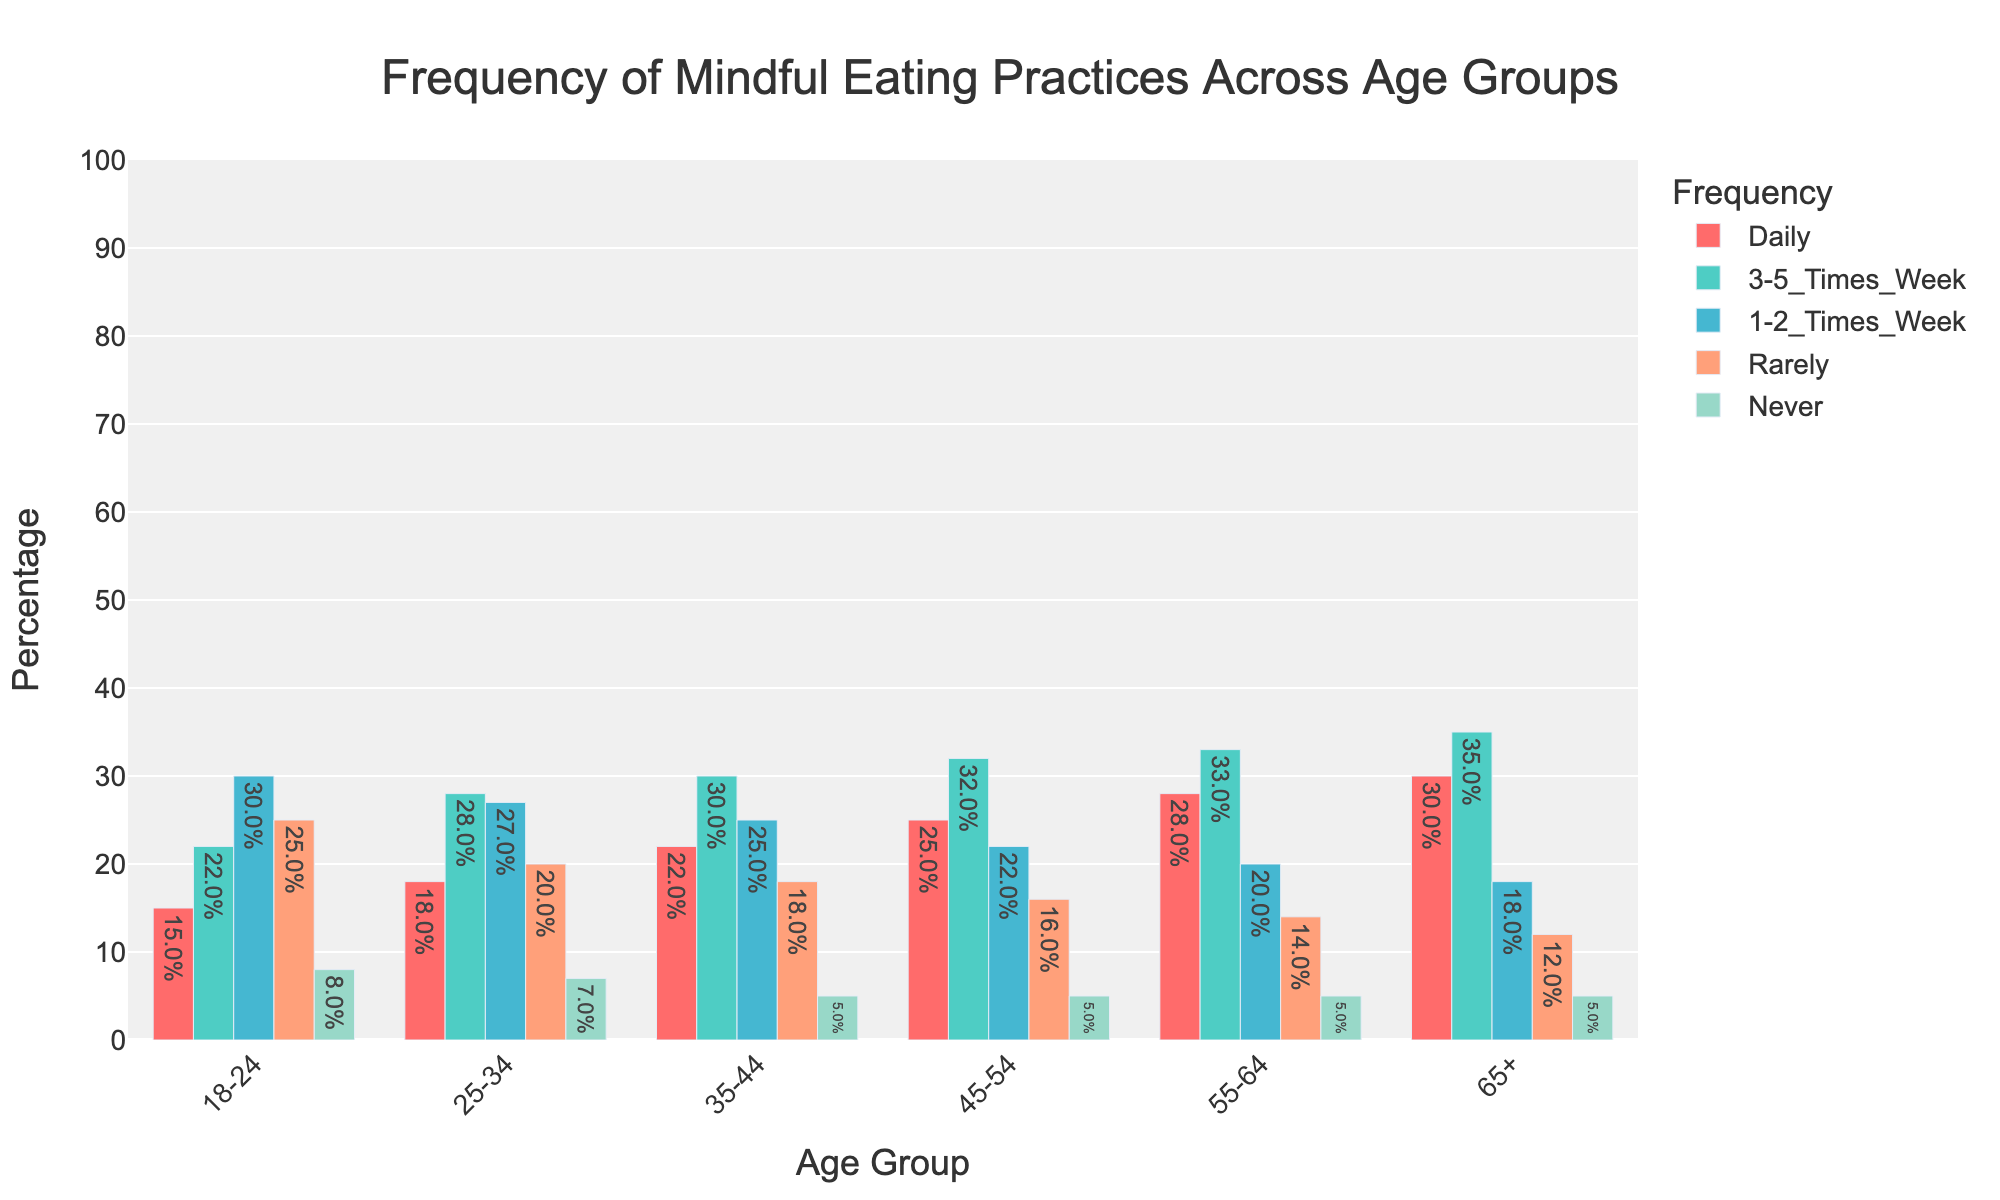What's the frequency of mindful eating practiced daily by the 18-24 age group? Look at the red bar corresponding to the '18-24' age group and refer to the data point at the top of the bar showing the percentage.
Answer: 15% Which age group practices mindful eating rarely the most? Look at the orange bars representing the "Rarely" category across all age groups. Find the highest value.
Answer: 18-24 age group What is the total percentage of individuals aged 65+ who practice mindful eating daily or 3-5 times a week? Add the percentages for the "Daily" and "3-5 Times/Week" bars for the "65+" age group: 30% + 35%.
Answer: 65% How many more individuals aged 55-64 practice mindful eating daily compared to those aged 35-44? Find the difference between the "Daily" category values for "55-64" and "35-44": 28% (55-64) - 22% (35-44).
Answer: 6% Which age group has the lowest percentage of individuals who never practice mindful eating? Look for the smallest value among the blue bars representing the "Never" category across all age groups.
Answer: Multiple groups (35-44, 45-54, 55-64, 65+) with 5% How does the "3-5 Times/Week" mindful eating practice frequency change with age? Compare the green bars for the "3-5 Times/Week" category across age groups. Notice that the percentage gradually increases with age.
Answer: Increases with age What is the average percentage of individuals practicing mindful eating 1-2 times a week across all age groups? Sum the "1-2 Times/Week" percentages for all age groups and divide by the number of age groups: (30+27+25+22+20+18)/6.
Answer: 23.67% Which age group shows the largest range in the frequency of mindful eating practices? Determine the range for each age group by subtracting the lowest percentage ("Never") from the highest percentage ("Daily" or "3-5 Times/Week"), and find the maximum. Example for 65+: 35% (3-5 Times/Week) - 5% (Never) = 30%.
Answer: 18-24 age group 